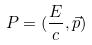Convert formula to latex. <formula><loc_0><loc_0><loc_500><loc_500>P = ( \frac { E } { c } , \vec { p } )</formula> 